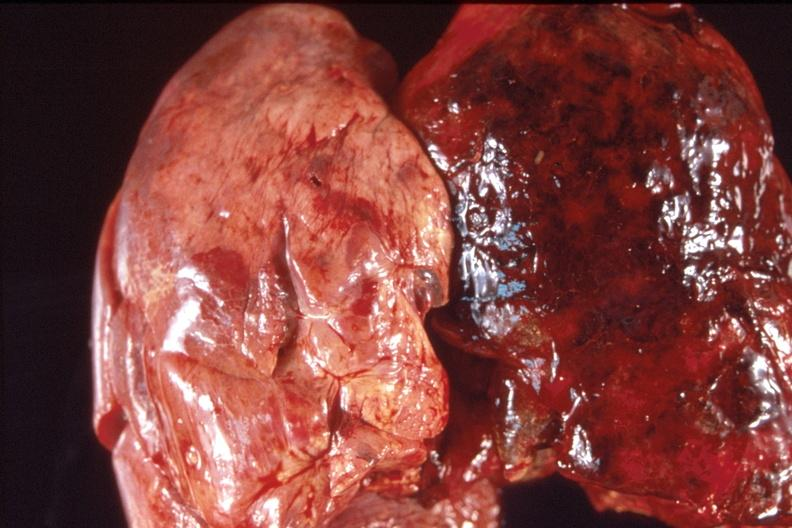what is present?
Answer the question using a single word or phrase. Respiratory 